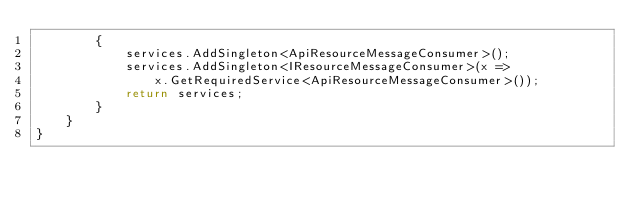Convert code to text. <code><loc_0><loc_0><loc_500><loc_500><_C#_>        {
            services.AddSingleton<ApiResourceMessageConsumer>();
            services.AddSingleton<IResourceMessageConsumer>(x =>
                x.GetRequiredService<ApiResourceMessageConsumer>());
            return services;
        }
    }
}
</code> 